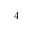Convert formula to latex. <formula><loc_0><loc_0><loc_500><loc_500>4</formula> 